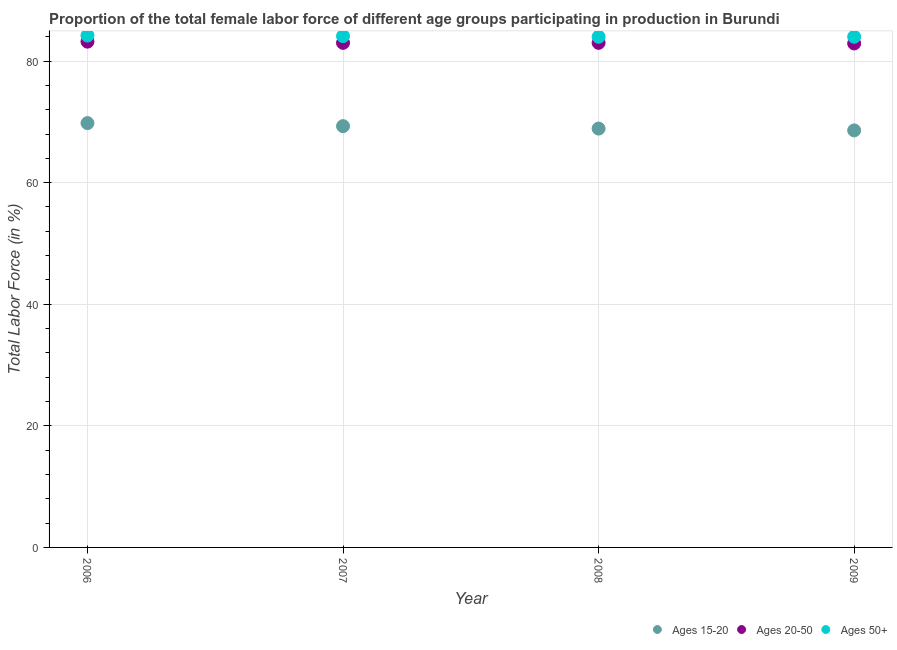Is the number of dotlines equal to the number of legend labels?
Offer a terse response. Yes. What is the percentage of female labor force within the age group 15-20 in 2009?
Your answer should be compact. 68.6. Across all years, what is the maximum percentage of female labor force within the age group 20-50?
Offer a very short reply. 83.2. Across all years, what is the minimum percentage of female labor force within the age group 20-50?
Ensure brevity in your answer.  82.9. In which year was the percentage of female labor force above age 50 maximum?
Keep it short and to the point. 2006. What is the total percentage of female labor force above age 50 in the graph?
Provide a succinct answer. 336.3. What is the difference between the percentage of female labor force within the age group 20-50 in 2006 and that in 2007?
Keep it short and to the point. 0.2. What is the difference between the percentage of female labor force above age 50 in 2006 and the percentage of female labor force within the age group 15-20 in 2009?
Your answer should be compact. 15.6. What is the average percentage of female labor force within the age group 20-50 per year?
Provide a succinct answer. 83.02. In the year 2009, what is the difference between the percentage of female labor force within the age group 20-50 and percentage of female labor force above age 50?
Give a very brief answer. -1.1. Is the percentage of female labor force above age 50 in 2007 less than that in 2008?
Offer a terse response. No. What is the difference between the highest and the second highest percentage of female labor force within the age group 20-50?
Your response must be concise. 0.2. What is the difference between the highest and the lowest percentage of female labor force within the age group 20-50?
Your answer should be very brief. 0.3. In how many years, is the percentage of female labor force above age 50 greater than the average percentage of female labor force above age 50 taken over all years?
Give a very brief answer. 2. Is the sum of the percentage of female labor force within the age group 20-50 in 2007 and 2008 greater than the maximum percentage of female labor force above age 50 across all years?
Your answer should be very brief. Yes. Is it the case that in every year, the sum of the percentage of female labor force within the age group 15-20 and percentage of female labor force within the age group 20-50 is greater than the percentage of female labor force above age 50?
Your answer should be very brief. Yes. Does the percentage of female labor force within the age group 20-50 monotonically increase over the years?
Your answer should be compact. No. Is the percentage of female labor force within the age group 15-20 strictly less than the percentage of female labor force within the age group 20-50 over the years?
Ensure brevity in your answer.  Yes. Are the values on the major ticks of Y-axis written in scientific E-notation?
Give a very brief answer. No. Where does the legend appear in the graph?
Ensure brevity in your answer.  Bottom right. What is the title of the graph?
Offer a very short reply. Proportion of the total female labor force of different age groups participating in production in Burundi. What is the label or title of the Y-axis?
Give a very brief answer. Total Labor Force (in %). What is the Total Labor Force (in %) of Ages 15-20 in 2006?
Give a very brief answer. 69.8. What is the Total Labor Force (in %) in Ages 20-50 in 2006?
Your answer should be very brief. 83.2. What is the Total Labor Force (in %) of Ages 50+ in 2006?
Your response must be concise. 84.2. What is the Total Labor Force (in %) of Ages 15-20 in 2007?
Offer a very short reply. 69.3. What is the Total Labor Force (in %) of Ages 50+ in 2007?
Give a very brief answer. 84.1. What is the Total Labor Force (in %) of Ages 15-20 in 2008?
Provide a succinct answer. 68.9. What is the Total Labor Force (in %) in Ages 50+ in 2008?
Make the answer very short. 84. What is the Total Labor Force (in %) of Ages 15-20 in 2009?
Your answer should be compact. 68.6. What is the Total Labor Force (in %) in Ages 20-50 in 2009?
Offer a terse response. 82.9. What is the Total Labor Force (in %) in Ages 50+ in 2009?
Your answer should be compact. 84. Across all years, what is the maximum Total Labor Force (in %) of Ages 15-20?
Your response must be concise. 69.8. Across all years, what is the maximum Total Labor Force (in %) in Ages 20-50?
Provide a succinct answer. 83.2. Across all years, what is the maximum Total Labor Force (in %) of Ages 50+?
Your response must be concise. 84.2. Across all years, what is the minimum Total Labor Force (in %) of Ages 15-20?
Ensure brevity in your answer.  68.6. Across all years, what is the minimum Total Labor Force (in %) of Ages 20-50?
Provide a succinct answer. 82.9. Across all years, what is the minimum Total Labor Force (in %) in Ages 50+?
Keep it short and to the point. 84. What is the total Total Labor Force (in %) of Ages 15-20 in the graph?
Your response must be concise. 276.6. What is the total Total Labor Force (in %) of Ages 20-50 in the graph?
Ensure brevity in your answer.  332.1. What is the total Total Labor Force (in %) of Ages 50+ in the graph?
Make the answer very short. 336.3. What is the difference between the Total Labor Force (in %) in Ages 15-20 in 2006 and that in 2007?
Provide a succinct answer. 0.5. What is the difference between the Total Labor Force (in %) in Ages 20-50 in 2006 and that in 2007?
Your response must be concise. 0.2. What is the difference between the Total Labor Force (in %) of Ages 15-20 in 2006 and that in 2008?
Your answer should be very brief. 0.9. What is the difference between the Total Labor Force (in %) of Ages 20-50 in 2006 and that in 2009?
Provide a short and direct response. 0.3. What is the difference between the Total Labor Force (in %) in Ages 15-20 in 2007 and that in 2008?
Your answer should be compact. 0.4. What is the difference between the Total Labor Force (in %) of Ages 15-20 in 2007 and that in 2009?
Your answer should be very brief. 0.7. What is the difference between the Total Labor Force (in %) in Ages 20-50 in 2007 and that in 2009?
Ensure brevity in your answer.  0.1. What is the difference between the Total Labor Force (in %) in Ages 50+ in 2007 and that in 2009?
Your answer should be compact. 0.1. What is the difference between the Total Labor Force (in %) in Ages 15-20 in 2008 and that in 2009?
Provide a short and direct response. 0.3. What is the difference between the Total Labor Force (in %) of Ages 50+ in 2008 and that in 2009?
Offer a terse response. 0. What is the difference between the Total Labor Force (in %) of Ages 15-20 in 2006 and the Total Labor Force (in %) of Ages 20-50 in 2007?
Provide a short and direct response. -13.2. What is the difference between the Total Labor Force (in %) of Ages 15-20 in 2006 and the Total Labor Force (in %) of Ages 50+ in 2007?
Provide a succinct answer. -14.3. What is the difference between the Total Labor Force (in %) in Ages 20-50 in 2006 and the Total Labor Force (in %) in Ages 50+ in 2007?
Offer a terse response. -0.9. What is the difference between the Total Labor Force (in %) of Ages 15-20 in 2006 and the Total Labor Force (in %) of Ages 20-50 in 2009?
Give a very brief answer. -13.1. What is the difference between the Total Labor Force (in %) of Ages 15-20 in 2007 and the Total Labor Force (in %) of Ages 20-50 in 2008?
Offer a very short reply. -13.7. What is the difference between the Total Labor Force (in %) in Ages 15-20 in 2007 and the Total Labor Force (in %) in Ages 50+ in 2008?
Provide a succinct answer. -14.7. What is the difference between the Total Labor Force (in %) in Ages 15-20 in 2007 and the Total Labor Force (in %) in Ages 20-50 in 2009?
Make the answer very short. -13.6. What is the difference between the Total Labor Force (in %) of Ages 15-20 in 2007 and the Total Labor Force (in %) of Ages 50+ in 2009?
Provide a short and direct response. -14.7. What is the difference between the Total Labor Force (in %) in Ages 20-50 in 2007 and the Total Labor Force (in %) in Ages 50+ in 2009?
Keep it short and to the point. -1. What is the difference between the Total Labor Force (in %) of Ages 15-20 in 2008 and the Total Labor Force (in %) of Ages 50+ in 2009?
Make the answer very short. -15.1. What is the difference between the Total Labor Force (in %) in Ages 20-50 in 2008 and the Total Labor Force (in %) in Ages 50+ in 2009?
Make the answer very short. -1. What is the average Total Labor Force (in %) of Ages 15-20 per year?
Make the answer very short. 69.15. What is the average Total Labor Force (in %) of Ages 20-50 per year?
Your response must be concise. 83.03. What is the average Total Labor Force (in %) of Ages 50+ per year?
Your answer should be very brief. 84.08. In the year 2006, what is the difference between the Total Labor Force (in %) of Ages 15-20 and Total Labor Force (in %) of Ages 50+?
Offer a very short reply. -14.4. In the year 2007, what is the difference between the Total Labor Force (in %) in Ages 15-20 and Total Labor Force (in %) in Ages 20-50?
Give a very brief answer. -13.7. In the year 2007, what is the difference between the Total Labor Force (in %) in Ages 15-20 and Total Labor Force (in %) in Ages 50+?
Your answer should be compact. -14.8. In the year 2007, what is the difference between the Total Labor Force (in %) of Ages 20-50 and Total Labor Force (in %) of Ages 50+?
Your response must be concise. -1.1. In the year 2008, what is the difference between the Total Labor Force (in %) in Ages 15-20 and Total Labor Force (in %) in Ages 20-50?
Keep it short and to the point. -14.1. In the year 2008, what is the difference between the Total Labor Force (in %) of Ages 15-20 and Total Labor Force (in %) of Ages 50+?
Your response must be concise. -15.1. In the year 2009, what is the difference between the Total Labor Force (in %) in Ages 15-20 and Total Labor Force (in %) in Ages 20-50?
Offer a terse response. -14.3. In the year 2009, what is the difference between the Total Labor Force (in %) in Ages 15-20 and Total Labor Force (in %) in Ages 50+?
Keep it short and to the point. -15.4. What is the ratio of the Total Labor Force (in %) of Ages 15-20 in 2006 to that in 2007?
Offer a terse response. 1.01. What is the ratio of the Total Labor Force (in %) in Ages 20-50 in 2006 to that in 2007?
Provide a short and direct response. 1. What is the ratio of the Total Labor Force (in %) in Ages 15-20 in 2006 to that in 2008?
Offer a terse response. 1.01. What is the ratio of the Total Labor Force (in %) in Ages 20-50 in 2006 to that in 2008?
Your answer should be compact. 1. What is the ratio of the Total Labor Force (in %) of Ages 15-20 in 2006 to that in 2009?
Your answer should be very brief. 1.02. What is the ratio of the Total Labor Force (in %) in Ages 20-50 in 2006 to that in 2009?
Provide a short and direct response. 1. What is the ratio of the Total Labor Force (in %) in Ages 50+ in 2006 to that in 2009?
Your answer should be very brief. 1. What is the ratio of the Total Labor Force (in %) in Ages 20-50 in 2007 to that in 2008?
Offer a very short reply. 1. What is the ratio of the Total Labor Force (in %) in Ages 15-20 in 2007 to that in 2009?
Your response must be concise. 1.01. What is the ratio of the Total Labor Force (in %) of Ages 50+ in 2007 to that in 2009?
Ensure brevity in your answer.  1. What is the ratio of the Total Labor Force (in %) in Ages 20-50 in 2008 to that in 2009?
Offer a terse response. 1. What is the difference between the highest and the second highest Total Labor Force (in %) of Ages 50+?
Make the answer very short. 0.1. What is the difference between the highest and the lowest Total Labor Force (in %) of Ages 15-20?
Your answer should be very brief. 1.2. What is the difference between the highest and the lowest Total Labor Force (in %) of Ages 20-50?
Your answer should be very brief. 0.3. 